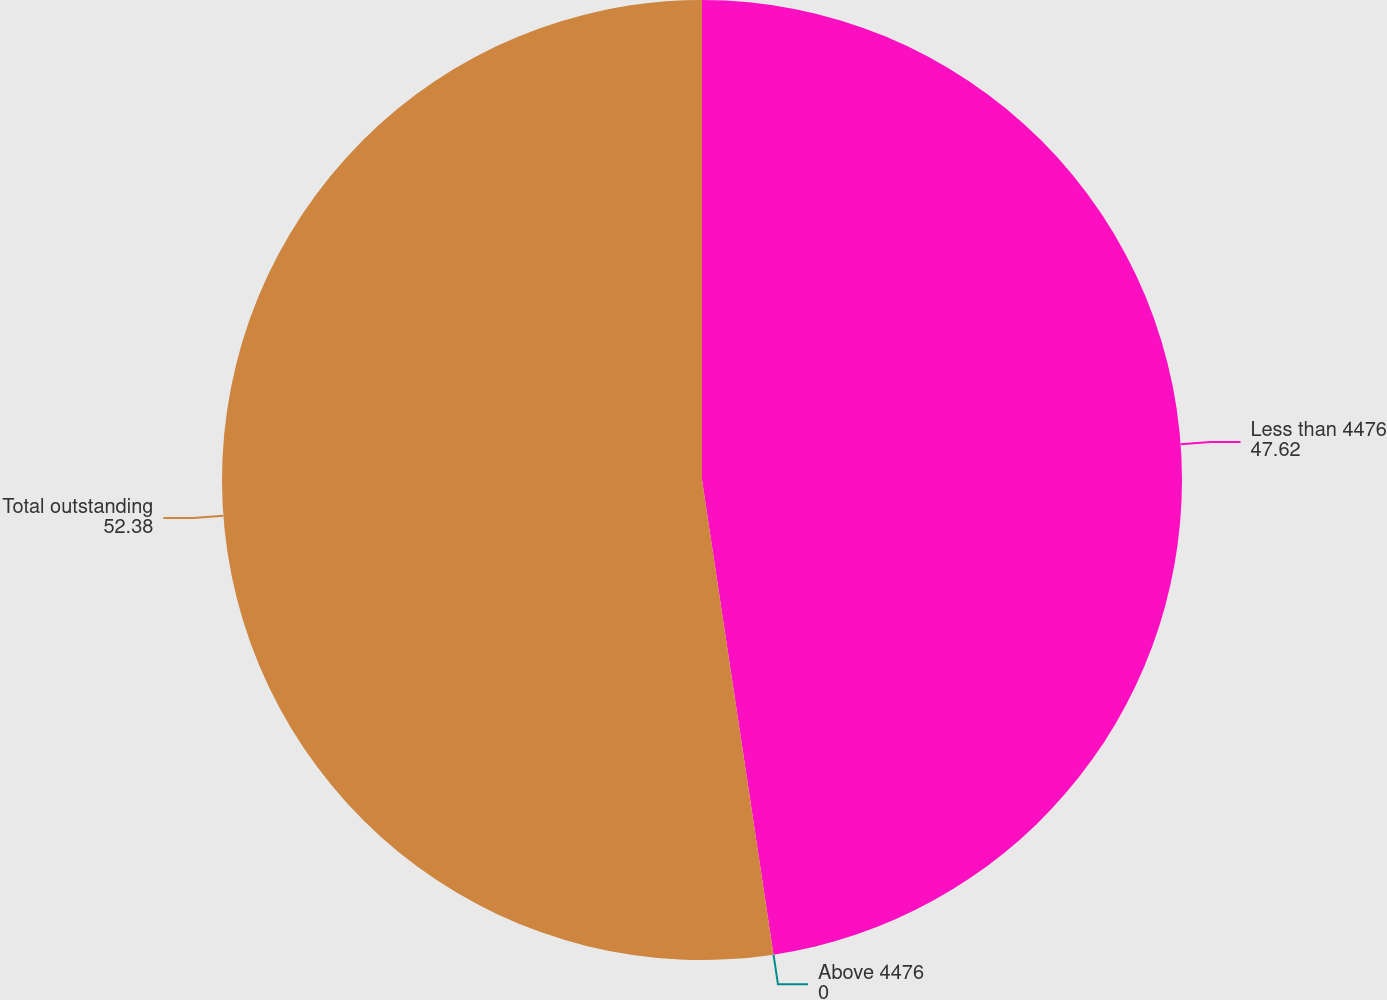Convert chart. <chart><loc_0><loc_0><loc_500><loc_500><pie_chart><fcel>Less than 4476<fcel>Above 4476<fcel>Total outstanding<nl><fcel>47.62%<fcel>0.0%<fcel>52.38%<nl></chart> 